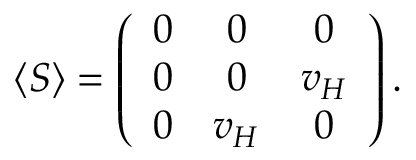<formula> <loc_0><loc_0><loc_500><loc_500>\langle S \rangle = \left ( \begin{array} { c c c } { 0 } & { 0 } & { 0 } \\ { 0 } & { 0 } & { { v _ { H } } } \\ { 0 } & { { v _ { H } } } & { 0 } \end{array} \right ) .</formula> 